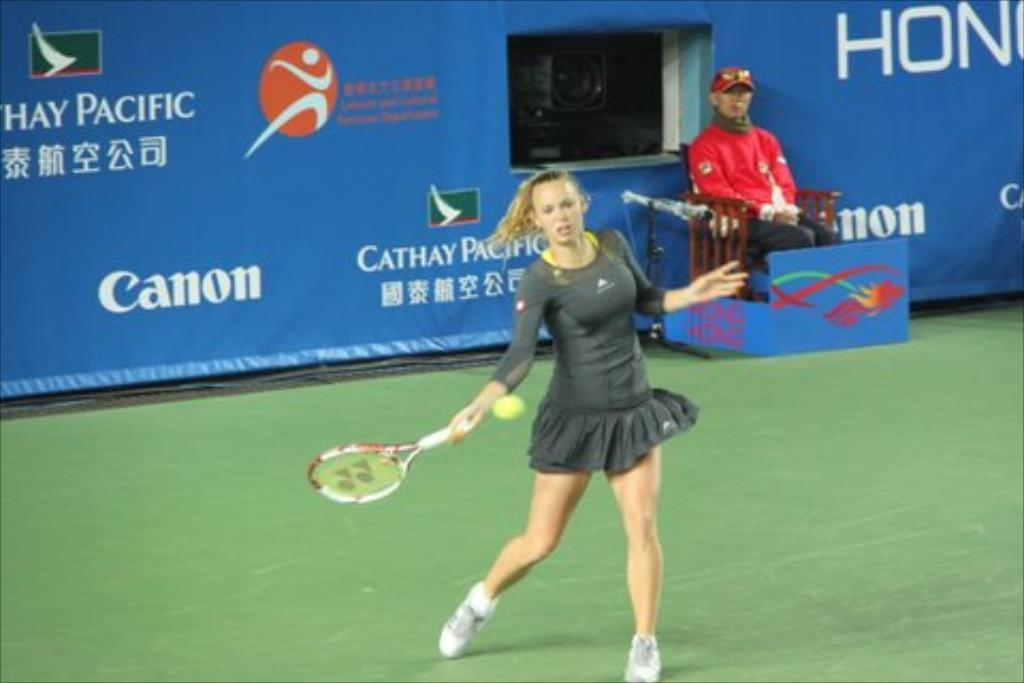What is the woman in the image holding? The woman is holding a racket in the image. What is happening with the ball in the image? There is a ball in the air in the image. Can you describe the person in the background of the image? There is a person sitting on a chair in the background of the image. What can be seen in the background of the image besides the person? There is a banner visible in the background of the image. What type of muscle is being exercised by the woman in the image? There is no indication of muscle exercise in the image; the woman is simply holding a racket. 